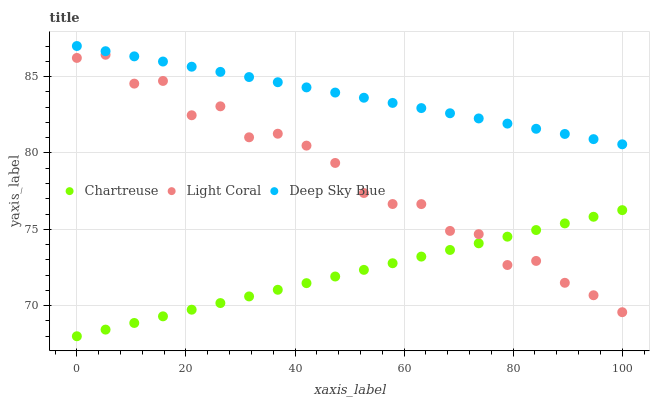Does Chartreuse have the minimum area under the curve?
Answer yes or no. Yes. Does Deep Sky Blue have the maximum area under the curve?
Answer yes or no. Yes. Does Deep Sky Blue have the minimum area under the curve?
Answer yes or no. No. Does Chartreuse have the maximum area under the curve?
Answer yes or no. No. Is Deep Sky Blue the smoothest?
Answer yes or no. Yes. Is Light Coral the roughest?
Answer yes or no. Yes. Is Chartreuse the smoothest?
Answer yes or no. No. Is Chartreuse the roughest?
Answer yes or no. No. Does Chartreuse have the lowest value?
Answer yes or no. Yes. Does Deep Sky Blue have the lowest value?
Answer yes or no. No. Does Deep Sky Blue have the highest value?
Answer yes or no. Yes. Does Chartreuse have the highest value?
Answer yes or no. No. Is Light Coral less than Deep Sky Blue?
Answer yes or no. Yes. Is Deep Sky Blue greater than Chartreuse?
Answer yes or no. Yes. Does Light Coral intersect Chartreuse?
Answer yes or no. Yes. Is Light Coral less than Chartreuse?
Answer yes or no. No. Is Light Coral greater than Chartreuse?
Answer yes or no. No. Does Light Coral intersect Deep Sky Blue?
Answer yes or no. No. 